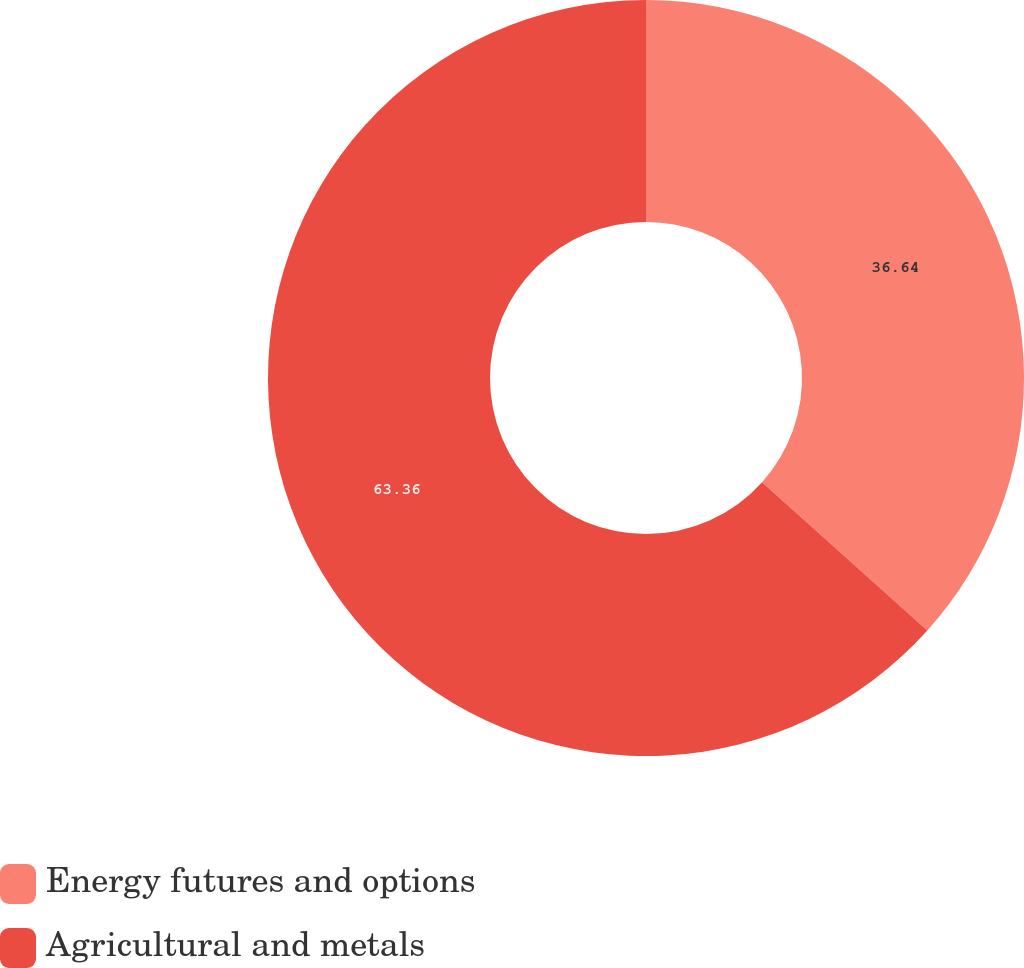Convert chart. <chart><loc_0><loc_0><loc_500><loc_500><pie_chart><fcel>Energy futures and options<fcel>Agricultural and metals<nl><fcel>36.64%<fcel>63.36%<nl></chart> 